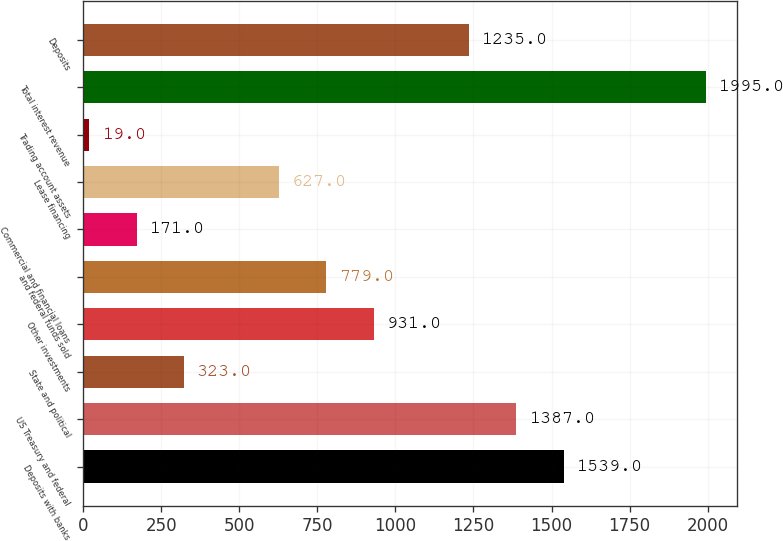<chart> <loc_0><loc_0><loc_500><loc_500><bar_chart><fcel>Deposits with banks<fcel>US Treasury and federal<fcel>State and political<fcel>Other investments<fcel>and federal funds sold<fcel>Commercial and financial loans<fcel>Lease financing<fcel>Trading account assets<fcel>Total interest revenue<fcel>Deposits<nl><fcel>1539<fcel>1387<fcel>323<fcel>931<fcel>779<fcel>171<fcel>627<fcel>19<fcel>1995<fcel>1235<nl></chart> 